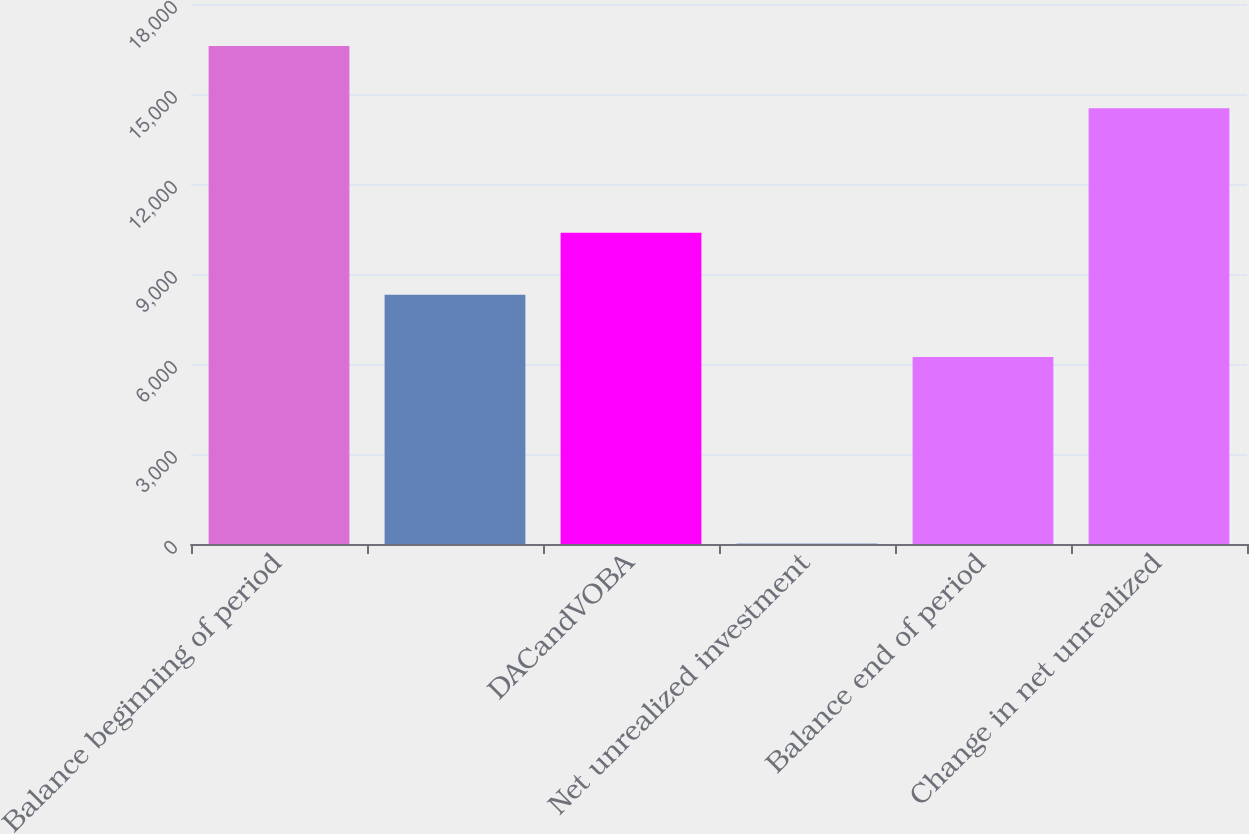Convert chart to OTSL. <chart><loc_0><loc_0><loc_500><loc_500><bar_chart><fcel>Balance beginning of period<fcel>Unnamed: 1<fcel>DACandVOBA<fcel>Net unrealized investment<fcel>Balance end of period<fcel>Change in net unrealized<nl><fcel>16598.2<fcel>8304.6<fcel>10378<fcel>11<fcel>6231.2<fcel>14524.8<nl></chart> 